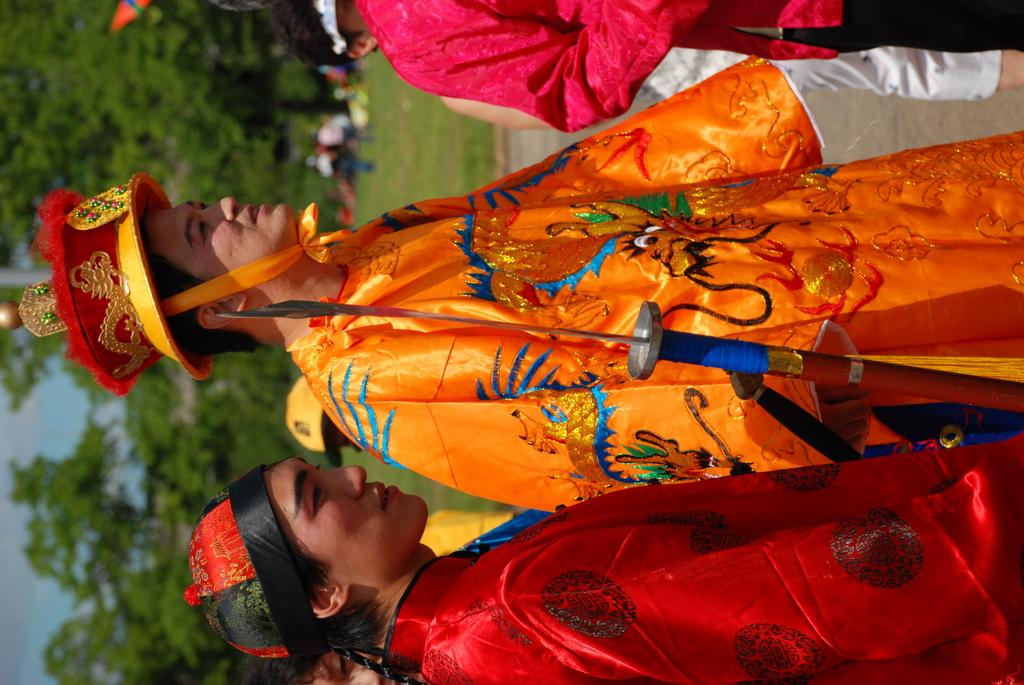How many persons can be seen in the image? There are persons in the image, but the exact number is not specified. What object with a knife is visible in the image? There is a wooden object with a knife in the image. What type of vegetation is visible behind the persons? There is a group of trees visible behind the persons. Can you describe the background of the image? The background of the image includes a group of trees, additional persons, grass, and the sky. What type of design can be seen on the fireman's uniform in the image? There is no fireman or uniform present in the image. How does the trick performed by the persons in the image work? There is no trick being performed by the persons in the image. 